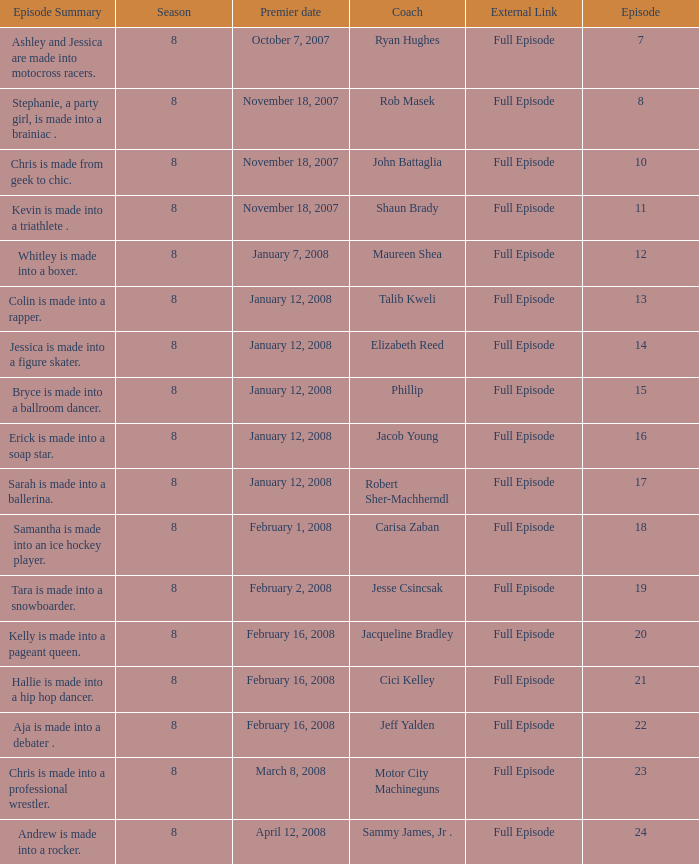Who was the mentor for episode 15? Phillip. 